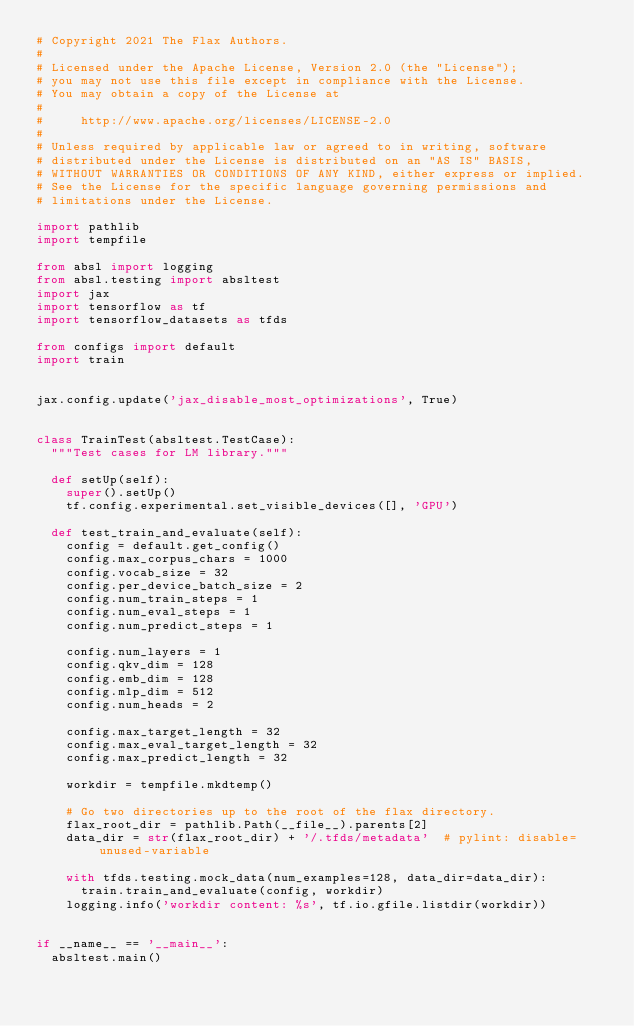<code> <loc_0><loc_0><loc_500><loc_500><_Python_># Copyright 2021 The Flax Authors.
#
# Licensed under the Apache License, Version 2.0 (the "License");
# you may not use this file except in compliance with the License.
# You may obtain a copy of the License at
#
#     http://www.apache.org/licenses/LICENSE-2.0
#
# Unless required by applicable law or agreed to in writing, software
# distributed under the License is distributed on an "AS IS" BASIS,
# WITHOUT WARRANTIES OR CONDITIONS OF ANY KIND, either express or implied.
# See the License for the specific language governing permissions and
# limitations under the License.

import pathlib
import tempfile

from absl import logging
from absl.testing import absltest
import jax
import tensorflow as tf
import tensorflow_datasets as tfds

from configs import default
import train


jax.config.update('jax_disable_most_optimizations', True)


class TrainTest(absltest.TestCase):
  """Test cases for LM library."""

  def setUp(self):
    super().setUp()
    tf.config.experimental.set_visible_devices([], 'GPU')

  def test_train_and_evaluate(self):
    config = default.get_config()
    config.max_corpus_chars = 1000
    config.vocab_size = 32
    config.per_device_batch_size = 2
    config.num_train_steps = 1
    config.num_eval_steps = 1
    config.num_predict_steps = 1

    config.num_layers = 1
    config.qkv_dim = 128
    config.emb_dim = 128
    config.mlp_dim = 512
    config.num_heads = 2

    config.max_target_length = 32
    config.max_eval_target_length = 32
    config.max_predict_length = 32

    workdir = tempfile.mkdtemp()

    # Go two directories up to the root of the flax directory.
    flax_root_dir = pathlib.Path(__file__).parents[2]
    data_dir = str(flax_root_dir) + '/.tfds/metadata'  # pylint: disable=unused-variable

    with tfds.testing.mock_data(num_examples=128, data_dir=data_dir):
      train.train_and_evaluate(config, workdir)
    logging.info('workdir content: %s', tf.io.gfile.listdir(workdir))


if __name__ == '__main__':
  absltest.main()
</code> 